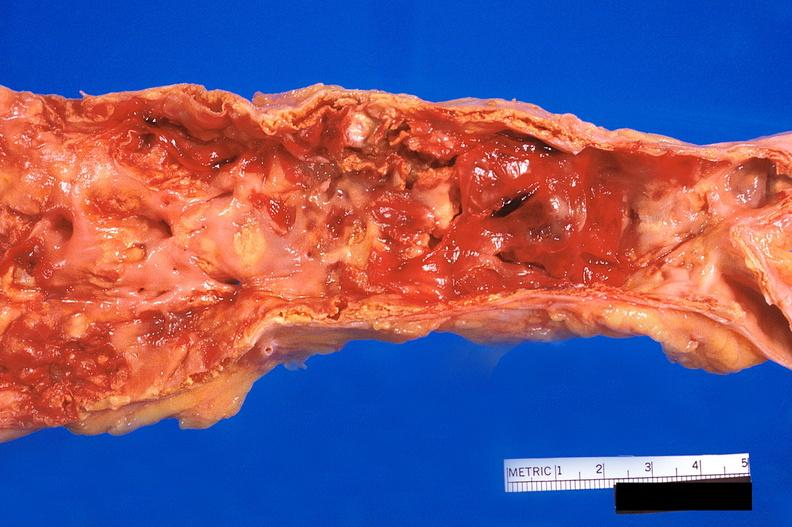does infant body show abdominal aorta, atherosclerosis and fusiform aneurysm?
Answer the question using a single word or phrase. No 